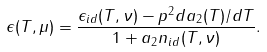<formula> <loc_0><loc_0><loc_500><loc_500>\epsilon ( T , \mu ) = \frac { \epsilon _ { i d } ( T , \nu ) - p ^ { 2 } d a _ { 2 } ( T ) / d T } { 1 + a _ { 2 } n _ { i d } ( T , \nu ) } .</formula> 